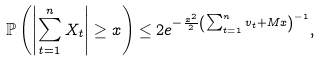<formula> <loc_0><loc_0><loc_500><loc_500>\mathbb { P } \left ( \left | \sum _ { t = 1 } ^ { n } X _ { t } \right | \geq x \right ) \leq 2 e ^ { - \frac { x ^ { 2 } } { 2 } \left ( \sum _ { t = 1 } ^ { n } v _ { t } + M x \right ) ^ { - 1 } } ,</formula> 